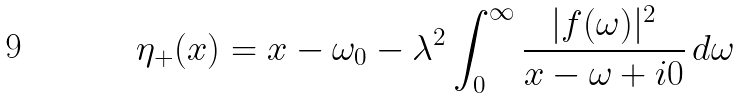Convert formula to latex. <formula><loc_0><loc_0><loc_500><loc_500>\eta _ { + } ( x ) = x - \omega _ { 0 } - \lambda ^ { 2 } \int _ { 0 } ^ { \infty } \frac { | f ( \omega ) | ^ { 2 } } { x - \omega + i 0 } \, d \omega</formula> 